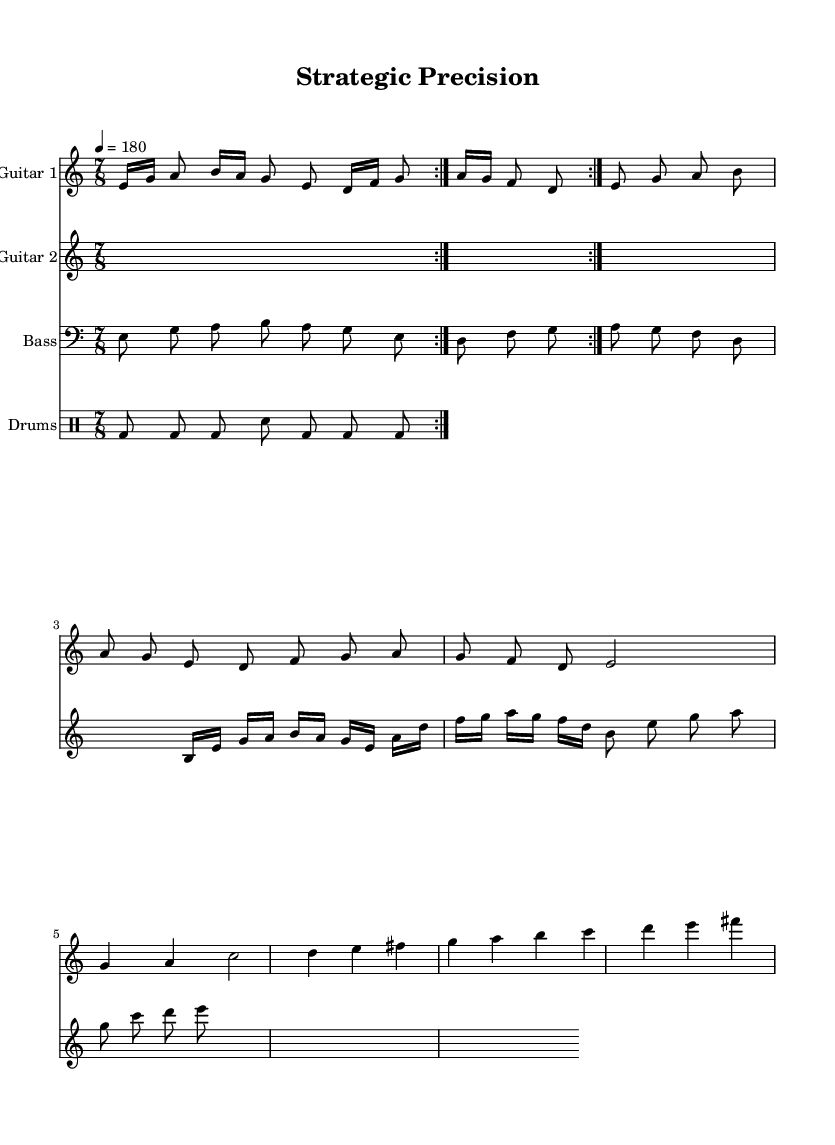What is the key signature of this music? The key signature is indicated by the key note at the beginning of the staff, which is E. In the context of this score, it is in E Phrygian mode.
Answer: E Phrygian What is the time signature of this music? The time signature is found at the beginning of the score, which indicates the measure structure. Here, it is 7/8, meaning there are 7 eighth notes per measure.
Answer: 7/8 What is the tempo marking for this piece? The tempo marking is given at the start of the score indicating the speed of the piece. Here, it is marked as 4 equals 180 beats per minute.
Answer: 180 How many measures are in the verse section? To determine the number of measures in the verse section, I count the measures from the music notation provided. The verse has 8 measures in total.
Answer: 8 What instrument is playing the main riff during the intro? The introduction (main riff) is played by Guitar 1, as indicated in the score where it begins with specified notes for that instrument.
Answer: Guitar 1 What rhythmic feel does the piece convey, and how does it align with the theme of sports management? The piece uses a complex time signature (7/8) which creates an uneven rhythmic feel, conveying strategy and precision, much like the careful planning required in sports management. This complexity reflects the multifaceted nature of coordinating a sports team.
Answer: Complex rhythm 